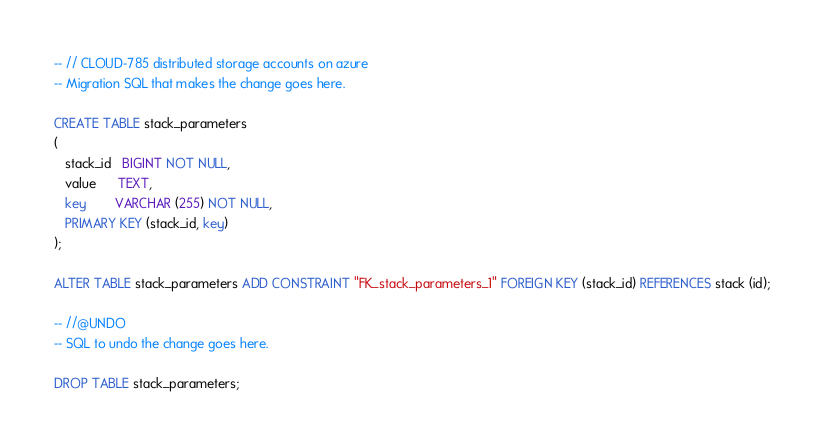Convert code to text. <code><loc_0><loc_0><loc_500><loc_500><_SQL_>-- // CLOUD-785 distributed storage accounts on azure
-- Migration SQL that makes the change goes here.

CREATE TABLE stack_parameters
(
   stack_id   BIGINT NOT NULL,
   value      TEXT,
   key        VARCHAR (255) NOT NULL,
   PRIMARY KEY (stack_id, key)
);

ALTER TABLE stack_parameters ADD CONSTRAINT "FK_stack_parameters_1" FOREIGN KEY (stack_id) REFERENCES stack (id);

-- //@UNDO
-- SQL to undo the change goes here.

DROP TABLE stack_parameters;


</code> 